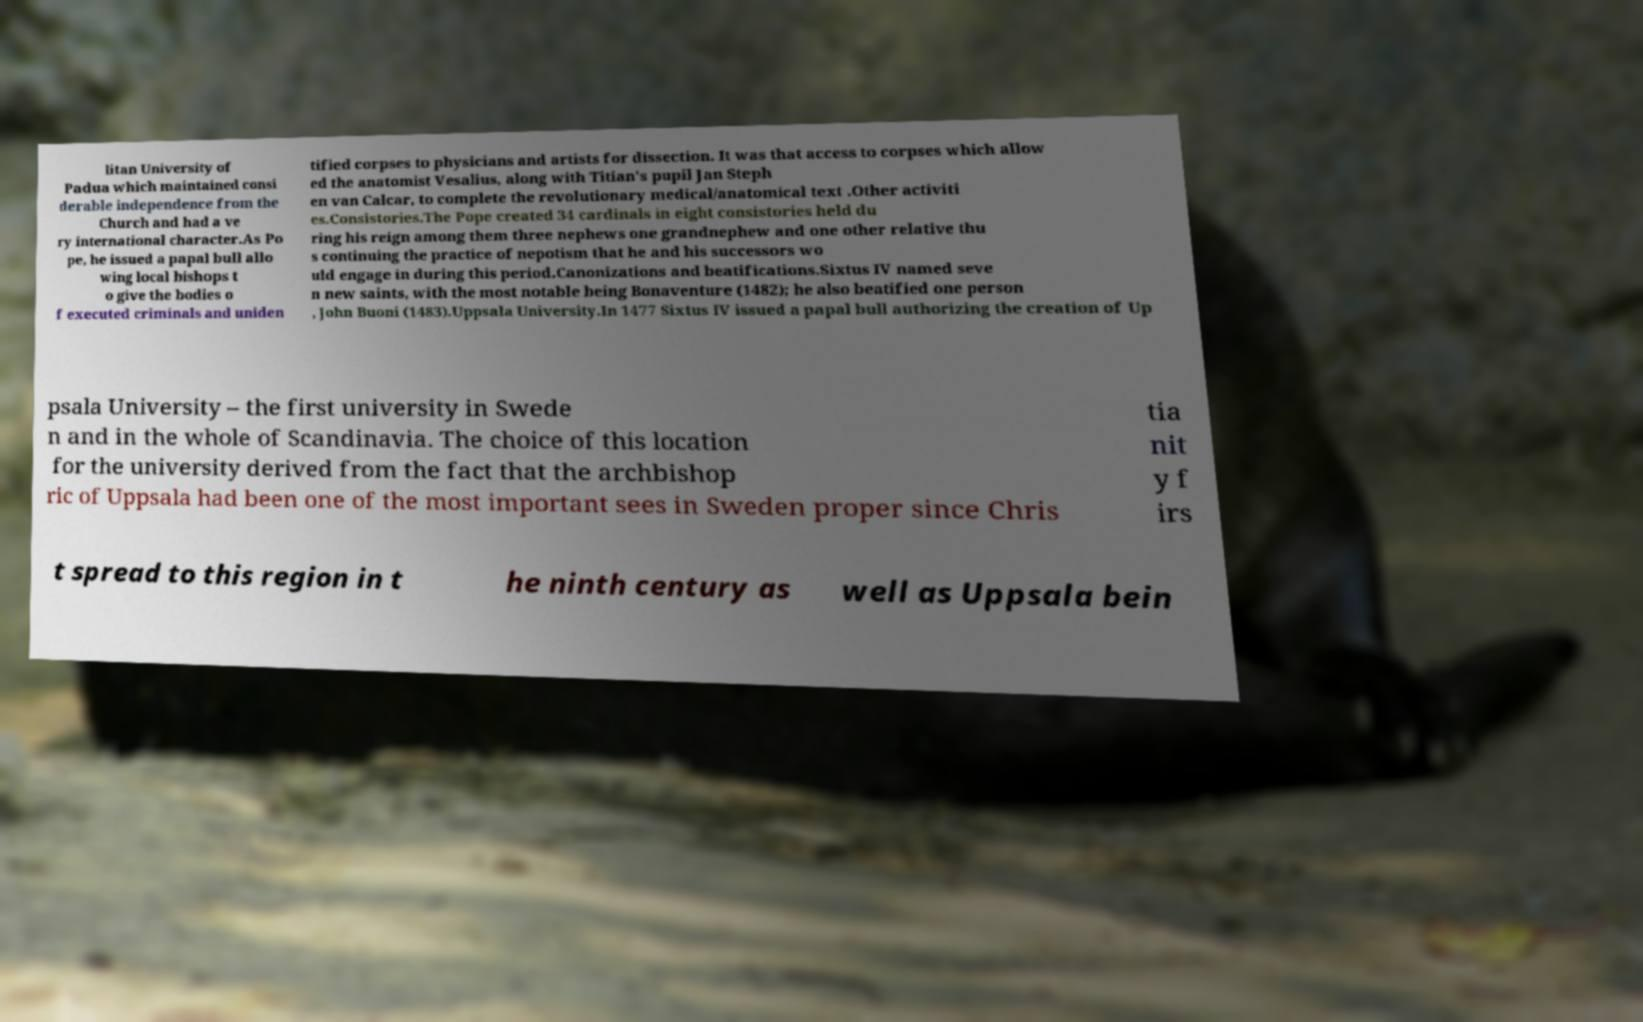Please identify and transcribe the text found in this image. litan University of Padua which maintained consi derable independence from the Church and had a ve ry international character.As Po pe, he issued a papal bull allo wing local bishops t o give the bodies o f executed criminals and uniden tified corpses to physicians and artists for dissection. It was that access to corpses which allow ed the anatomist Vesalius, along with Titian's pupil Jan Steph en van Calcar, to complete the revolutionary medical/anatomical text .Other activiti es.Consistories.The Pope created 34 cardinals in eight consistories held du ring his reign among them three nephews one grandnephew and one other relative thu s continuing the practice of nepotism that he and his successors wo uld engage in during this period.Canonizations and beatifications.Sixtus IV named seve n new saints, with the most notable being Bonaventure (1482); he also beatified one person , John Buoni (1483).Uppsala University.In 1477 Sixtus IV issued a papal bull authorizing the creation of Up psala University – the first university in Swede n and in the whole of Scandinavia. The choice of this location for the university derived from the fact that the archbishop ric of Uppsala had been one of the most important sees in Sweden proper since Chris tia nit y f irs t spread to this region in t he ninth century as well as Uppsala bein 